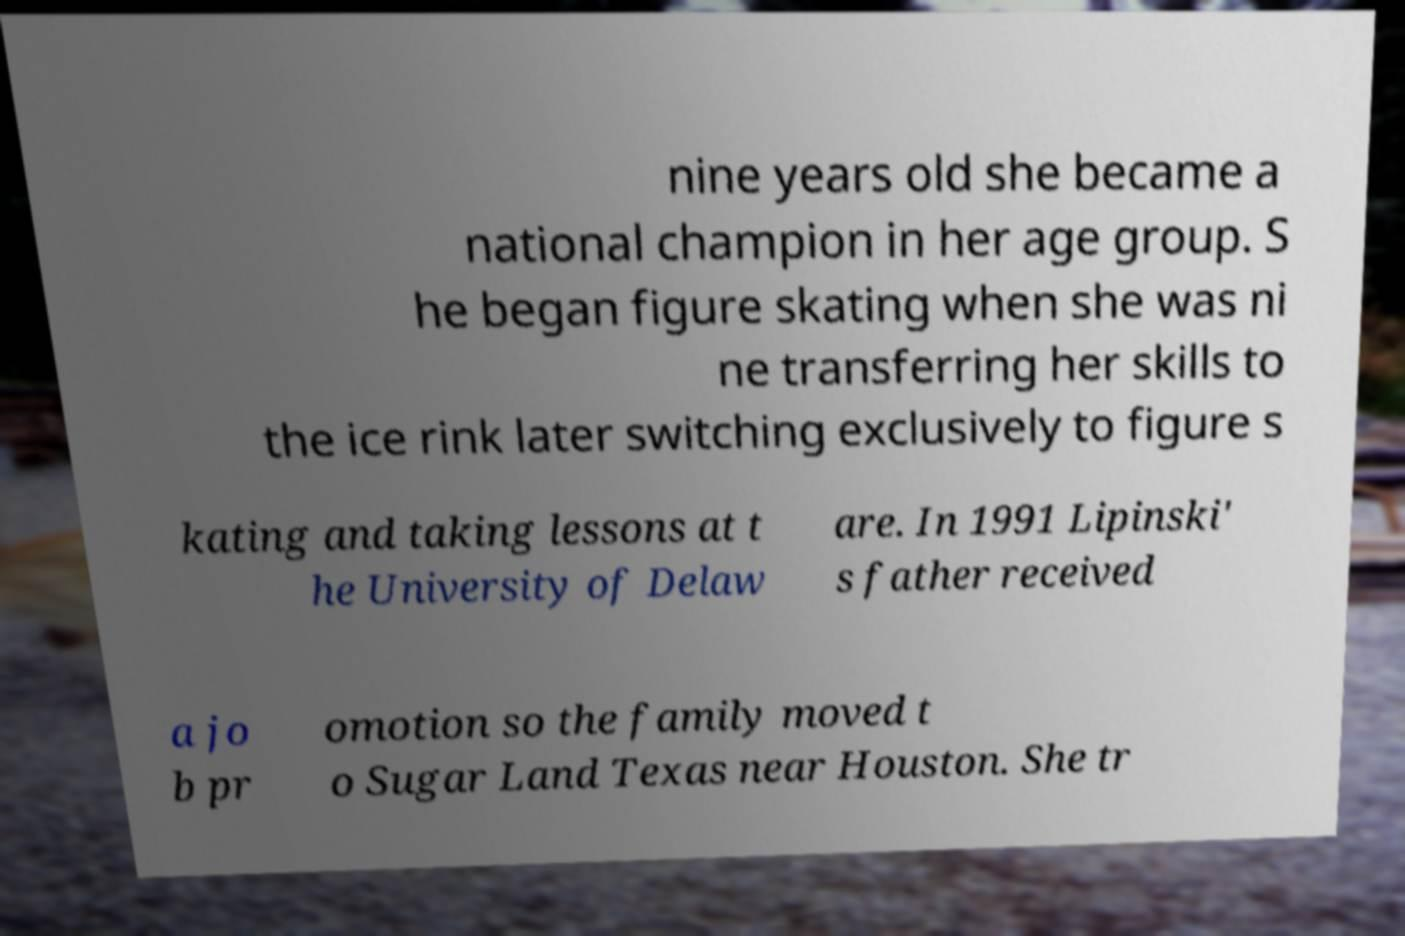Can you accurately transcribe the text from the provided image for me? nine years old she became a national champion in her age group. S he began figure skating when she was ni ne transferring her skills to the ice rink later switching exclusively to figure s kating and taking lessons at t he University of Delaw are. In 1991 Lipinski' s father received a jo b pr omotion so the family moved t o Sugar Land Texas near Houston. She tr 